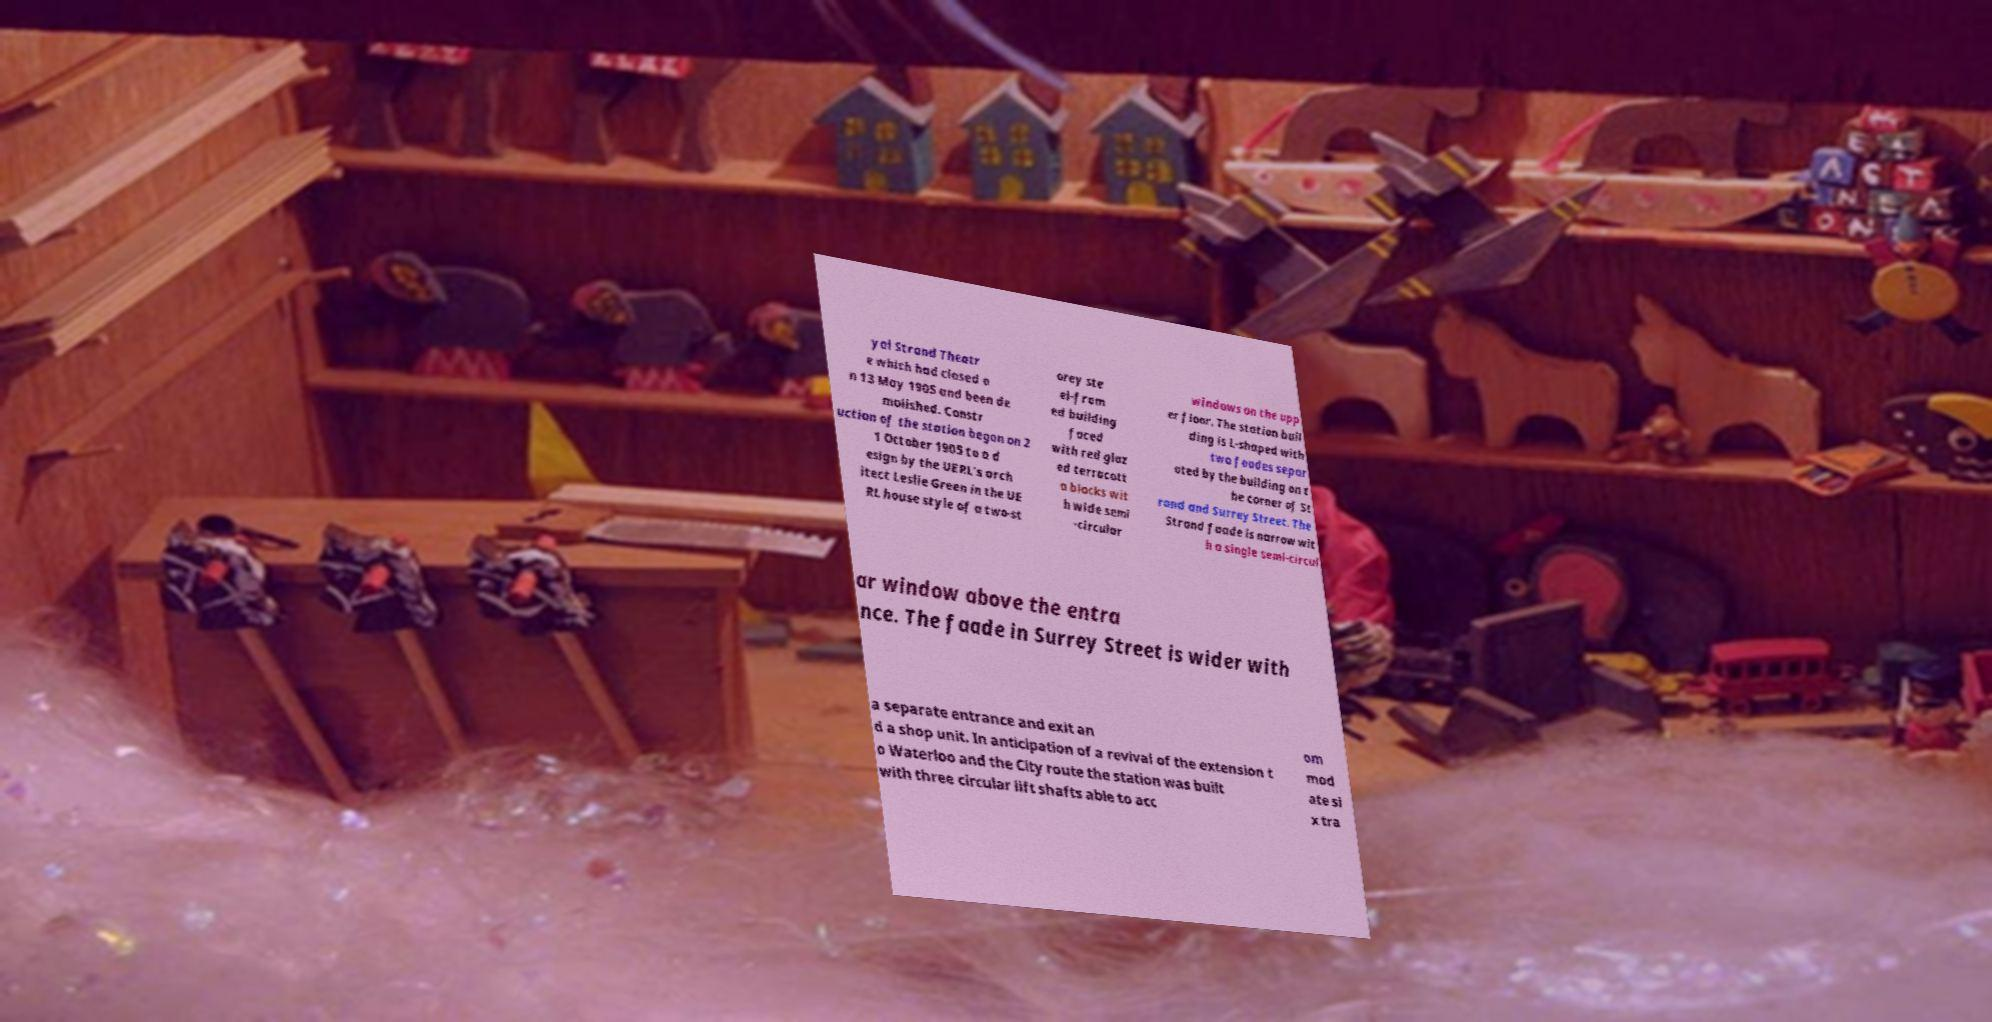Could you extract and type out the text from this image? yal Strand Theatr e which had closed o n 13 May 1905 and been de molished. Constr uction of the station began on 2 1 October 1905 to a d esign by the UERL's arch itect Leslie Green in the UE RL house style of a two-st orey ste el-fram ed building faced with red glaz ed terracott a blocks wit h wide semi -circular windows on the upp er floor. The station buil ding is L-shaped with two faades separ ated by the building on t he corner of St rand and Surrey Street. The Strand faade is narrow wit h a single semi-circul ar window above the entra nce. The faade in Surrey Street is wider with a separate entrance and exit an d a shop unit. In anticipation of a revival of the extension t o Waterloo and the City route the station was built with three circular lift shafts able to acc om mod ate si x tra 